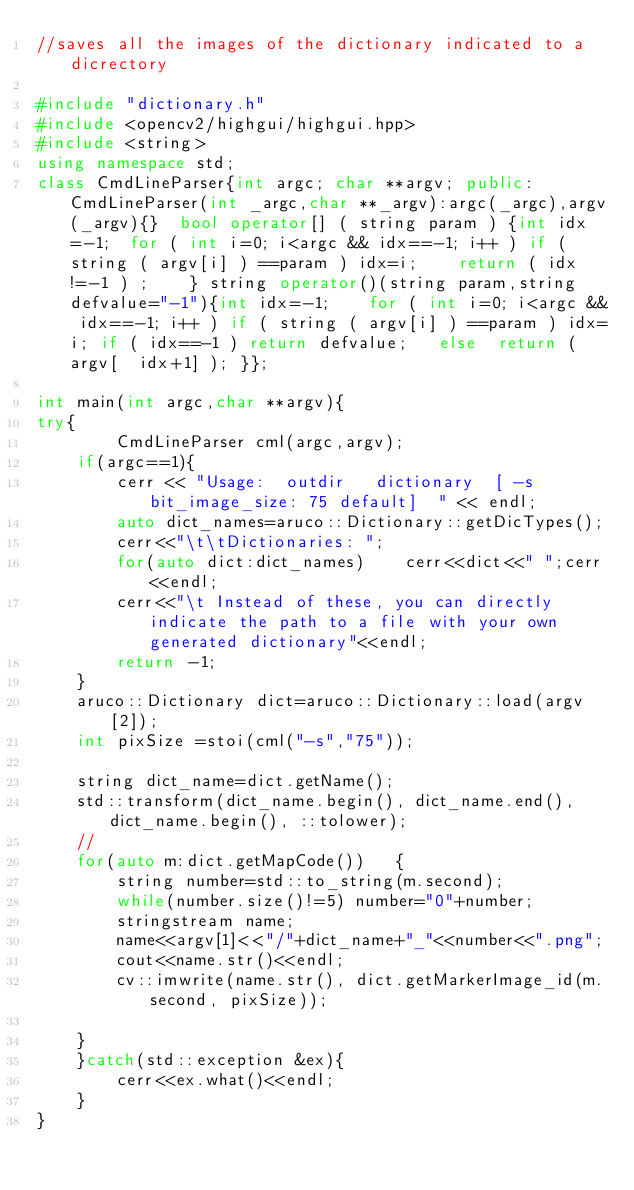<code> <loc_0><loc_0><loc_500><loc_500><_C++_>//saves all the images of the dictionary indicated to a dicrectory

#include "dictionary.h"
#include <opencv2/highgui/highgui.hpp>
#include <string>
using namespace std;
class CmdLineParser{int argc; char **argv; public: CmdLineParser(int _argc,char **_argv):argc(_argc),argv(_argv){}  bool operator[] ( string param ) {int idx=-1;  for ( int i=0; i<argc && idx==-1; i++ ) if ( string ( argv[i] ) ==param ) idx=i;    return ( idx!=-1 ) ;    } string operator()(string param,string defvalue="-1"){int idx=-1;    for ( int i=0; i<argc && idx==-1; i++ ) if ( string ( argv[i] ) ==param ) idx=i; if ( idx==-1 ) return defvalue;   else  return ( argv[  idx+1] ); }};

int main(int argc,char **argv){
try{
        CmdLineParser cml(argc,argv);
    if(argc==1){
        cerr << "Usage:  outdir   dictionary  [ -s bit_image_size: 75 default]  " << endl;
        auto dict_names=aruco::Dictionary::getDicTypes();
        cerr<<"\t\tDictionaries: ";
        for(auto dict:dict_names)    cerr<<dict<<" ";cerr<<endl;
        cerr<<"\t Instead of these, you can directly indicate the path to a file with your own generated dictionary"<<endl;
        return -1;
    }
    aruco::Dictionary dict=aruco::Dictionary::load(argv[2]);
    int pixSize =stoi(cml("-s","75"));

    string dict_name=dict.getName();
    std::transform(dict_name.begin(), dict_name.end(), dict_name.begin(), ::tolower);
    //
    for(auto m:dict.getMapCode())   {
        string number=std::to_string(m.second);
        while(number.size()!=5) number="0"+number;
        stringstream name;
        name<<argv[1]<<"/"+dict_name+"_"<<number<<".png";
        cout<<name.str()<<endl;
        cv::imwrite(name.str(), dict.getMarkerImage_id(m.second, pixSize));

    }
    }catch(std::exception &ex){
        cerr<<ex.what()<<endl;
    }
}
</code> 